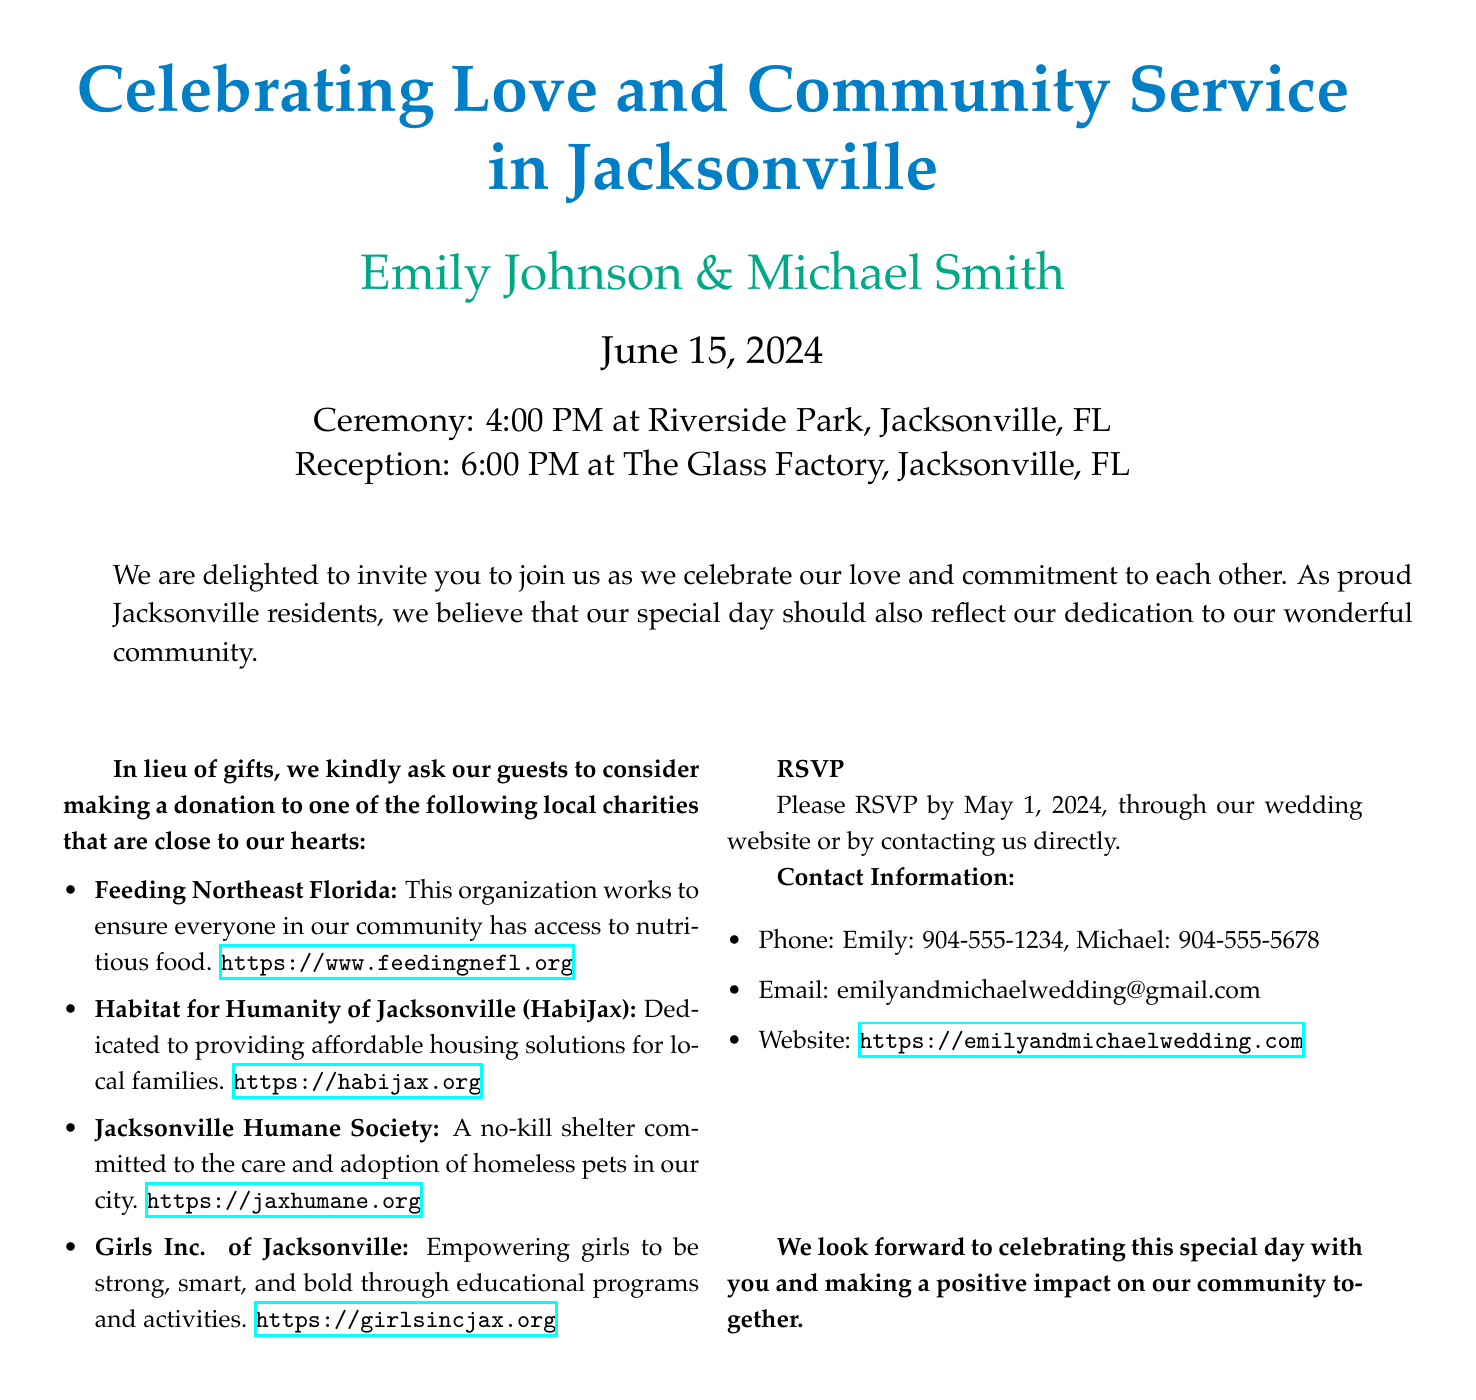What is the date of the wedding? The date of the wedding is clearly stated in the document as June 15, 2024.
Answer: June 15, 2024 Who are the couple getting married? The names of the couple are prominently featured in the document, which are Emily Johnson and Michael Smith.
Answer: Emily Johnson & Michael Smith What time does the ceremony start? The starting time of the ceremony is specified in the document as 4:00 PM.
Answer: 4:00 PM Which charity supports affordable housing solutions? The charity providing affordable housing solutions is identified in the document as Habitat for Humanity of Jacksonville (HabiJax).
Answer: Habitat for Humanity of Jacksonville (HabiJax) What is the RSVP deadline? The deadline for RSVPs is clearly mentioned in the document as May 1, 2024.
Answer: May 1, 2024 What is the primary theme of the invitation? The main theme reflected in the invitation is a celebration of love that includes a commitment to community service.
Answer: Community service How many charities are mentioned in the invitation? The document lists a total of four local charities for donations in lieu of gifts.
Answer: Four What symbol represents the Jacksonville community in the invitation? The document does not explicitly mention a symbol but highlights a commitment to the Jacksonville community as part of the wedding theme.
Answer: Jacksonville community What contact method is available for RSVPs? The invitation provides multiple contact methods, including phone and email for guests to RSVP.
Answer: Phone and email 